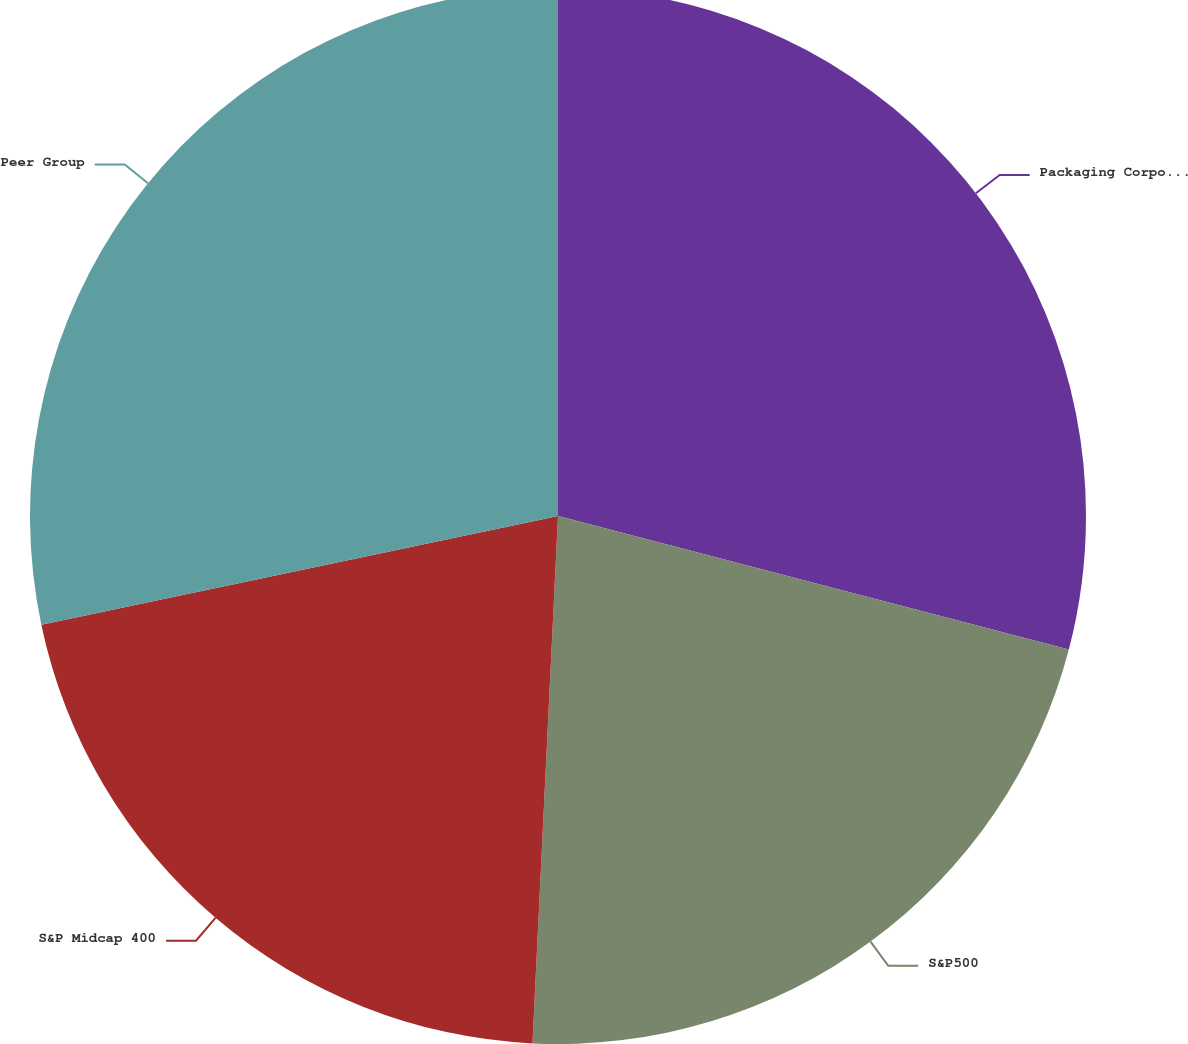<chart> <loc_0><loc_0><loc_500><loc_500><pie_chart><fcel>Packaging Corporation of<fcel>S&P500<fcel>S&P Midcap 400<fcel>Peer Group<nl><fcel>29.07%<fcel>21.7%<fcel>20.93%<fcel>28.3%<nl></chart> 